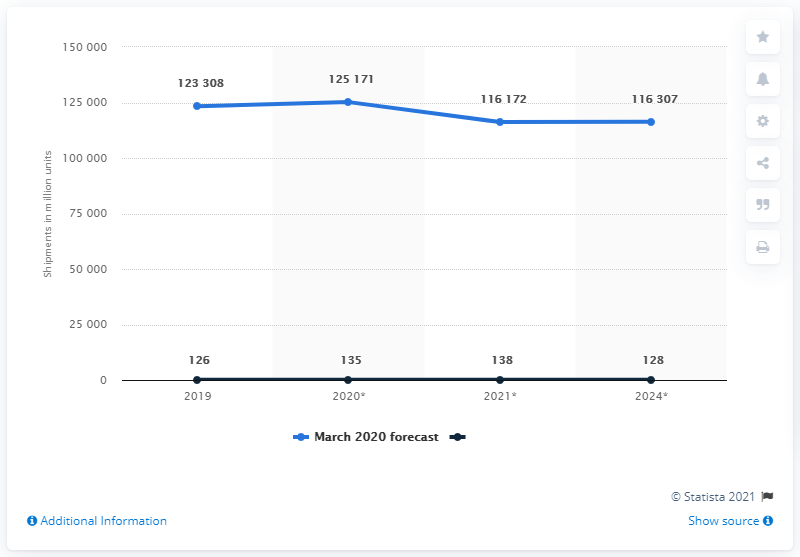Point out several critical features in this image. According to the information available, the total unit shipments of personal computer monitors worldwide in 2019 and 2020 were approximately 248,479. It is expected that 135 PC monitors will be shipped in 2020. It is expected that more PC monitors will be sold in 2020 than in 2019, by approximately 135 units. In 2019, the number of personal computer monitor unit shipments worldwide was approximately 123,308. 